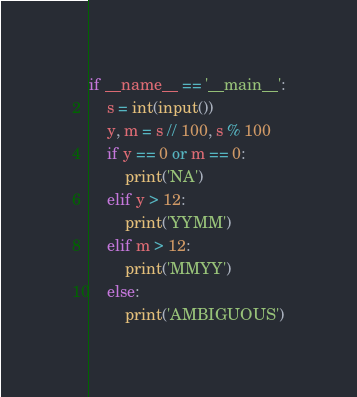Convert code to text. <code><loc_0><loc_0><loc_500><loc_500><_Python_>if __name__ == '__main__':
    s = int(input())
    y, m = s // 100, s % 100
    if y == 0 or m == 0:
        print('NA')
    elif y > 12:
        print('YYMM')
    elif m > 12:
        print('MMYY')
    else:
        print('AMBIGUOUS')
</code> 